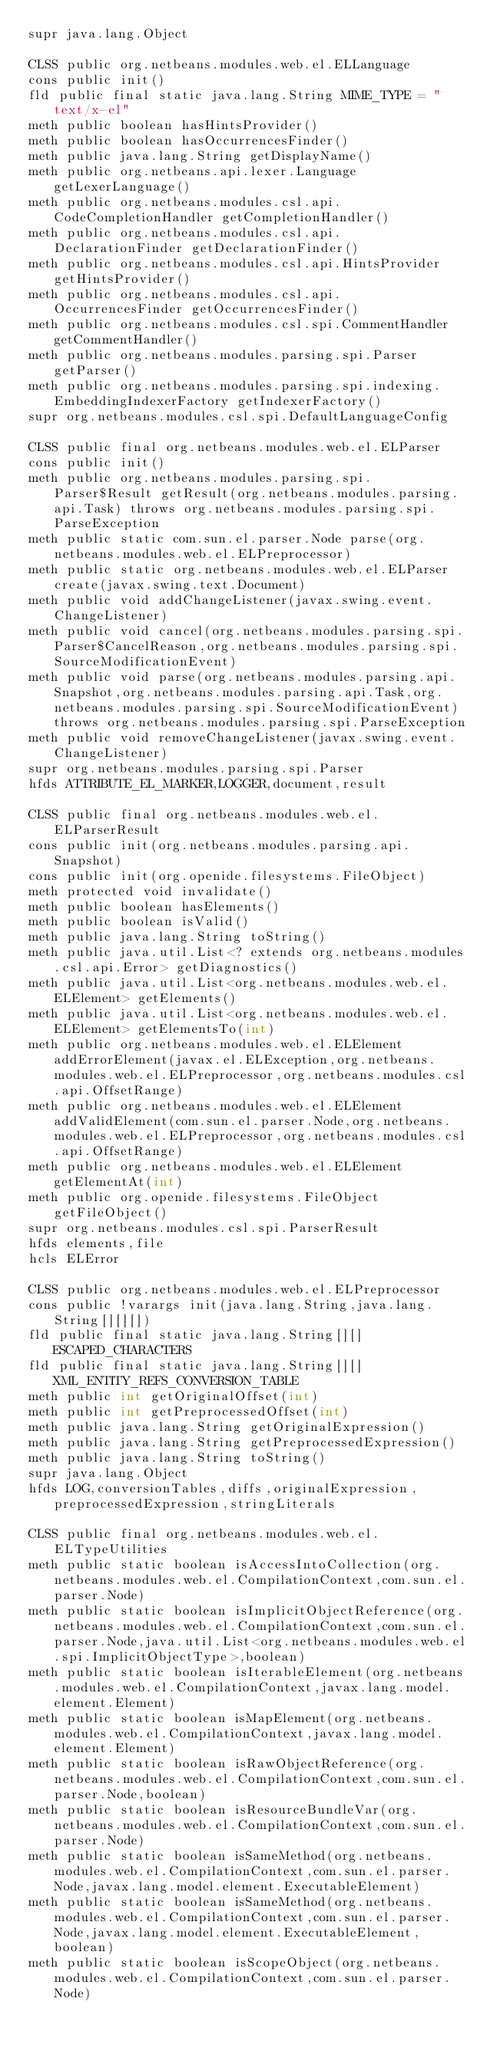<code> <loc_0><loc_0><loc_500><loc_500><_SML_>supr java.lang.Object

CLSS public org.netbeans.modules.web.el.ELLanguage
cons public init()
fld public final static java.lang.String MIME_TYPE = "text/x-el"
meth public boolean hasHintsProvider()
meth public boolean hasOccurrencesFinder()
meth public java.lang.String getDisplayName()
meth public org.netbeans.api.lexer.Language getLexerLanguage()
meth public org.netbeans.modules.csl.api.CodeCompletionHandler getCompletionHandler()
meth public org.netbeans.modules.csl.api.DeclarationFinder getDeclarationFinder()
meth public org.netbeans.modules.csl.api.HintsProvider getHintsProvider()
meth public org.netbeans.modules.csl.api.OccurrencesFinder getOccurrencesFinder()
meth public org.netbeans.modules.csl.spi.CommentHandler getCommentHandler()
meth public org.netbeans.modules.parsing.spi.Parser getParser()
meth public org.netbeans.modules.parsing.spi.indexing.EmbeddingIndexerFactory getIndexerFactory()
supr org.netbeans.modules.csl.spi.DefaultLanguageConfig

CLSS public final org.netbeans.modules.web.el.ELParser
cons public init()
meth public org.netbeans.modules.parsing.spi.Parser$Result getResult(org.netbeans.modules.parsing.api.Task) throws org.netbeans.modules.parsing.spi.ParseException
meth public static com.sun.el.parser.Node parse(org.netbeans.modules.web.el.ELPreprocessor)
meth public static org.netbeans.modules.web.el.ELParser create(javax.swing.text.Document)
meth public void addChangeListener(javax.swing.event.ChangeListener)
meth public void cancel(org.netbeans.modules.parsing.spi.Parser$CancelReason,org.netbeans.modules.parsing.spi.SourceModificationEvent)
meth public void parse(org.netbeans.modules.parsing.api.Snapshot,org.netbeans.modules.parsing.api.Task,org.netbeans.modules.parsing.spi.SourceModificationEvent) throws org.netbeans.modules.parsing.spi.ParseException
meth public void removeChangeListener(javax.swing.event.ChangeListener)
supr org.netbeans.modules.parsing.spi.Parser
hfds ATTRIBUTE_EL_MARKER,LOGGER,document,result

CLSS public final org.netbeans.modules.web.el.ELParserResult
cons public init(org.netbeans.modules.parsing.api.Snapshot)
cons public init(org.openide.filesystems.FileObject)
meth protected void invalidate()
meth public boolean hasElements()
meth public boolean isValid()
meth public java.lang.String toString()
meth public java.util.List<? extends org.netbeans.modules.csl.api.Error> getDiagnostics()
meth public java.util.List<org.netbeans.modules.web.el.ELElement> getElements()
meth public java.util.List<org.netbeans.modules.web.el.ELElement> getElementsTo(int)
meth public org.netbeans.modules.web.el.ELElement addErrorElement(javax.el.ELException,org.netbeans.modules.web.el.ELPreprocessor,org.netbeans.modules.csl.api.OffsetRange)
meth public org.netbeans.modules.web.el.ELElement addValidElement(com.sun.el.parser.Node,org.netbeans.modules.web.el.ELPreprocessor,org.netbeans.modules.csl.api.OffsetRange)
meth public org.netbeans.modules.web.el.ELElement getElementAt(int)
meth public org.openide.filesystems.FileObject getFileObject()
supr org.netbeans.modules.csl.spi.ParserResult
hfds elements,file
hcls ELError

CLSS public org.netbeans.modules.web.el.ELPreprocessor
cons public !varargs init(java.lang.String,java.lang.String[][][])
fld public final static java.lang.String[][] ESCAPED_CHARACTERS
fld public final static java.lang.String[][] XML_ENTITY_REFS_CONVERSION_TABLE
meth public int getOriginalOffset(int)
meth public int getPreprocessedOffset(int)
meth public java.lang.String getOriginalExpression()
meth public java.lang.String getPreprocessedExpression()
meth public java.lang.String toString()
supr java.lang.Object
hfds LOG,conversionTables,diffs,originalExpression,preprocessedExpression,stringLiterals

CLSS public final org.netbeans.modules.web.el.ELTypeUtilities
meth public static boolean isAccessIntoCollection(org.netbeans.modules.web.el.CompilationContext,com.sun.el.parser.Node)
meth public static boolean isImplicitObjectReference(org.netbeans.modules.web.el.CompilationContext,com.sun.el.parser.Node,java.util.List<org.netbeans.modules.web.el.spi.ImplicitObjectType>,boolean)
meth public static boolean isIterableElement(org.netbeans.modules.web.el.CompilationContext,javax.lang.model.element.Element)
meth public static boolean isMapElement(org.netbeans.modules.web.el.CompilationContext,javax.lang.model.element.Element)
meth public static boolean isRawObjectReference(org.netbeans.modules.web.el.CompilationContext,com.sun.el.parser.Node,boolean)
meth public static boolean isResourceBundleVar(org.netbeans.modules.web.el.CompilationContext,com.sun.el.parser.Node)
meth public static boolean isSameMethod(org.netbeans.modules.web.el.CompilationContext,com.sun.el.parser.Node,javax.lang.model.element.ExecutableElement)
meth public static boolean isSameMethod(org.netbeans.modules.web.el.CompilationContext,com.sun.el.parser.Node,javax.lang.model.element.ExecutableElement,boolean)
meth public static boolean isScopeObject(org.netbeans.modules.web.el.CompilationContext,com.sun.el.parser.Node)</code> 